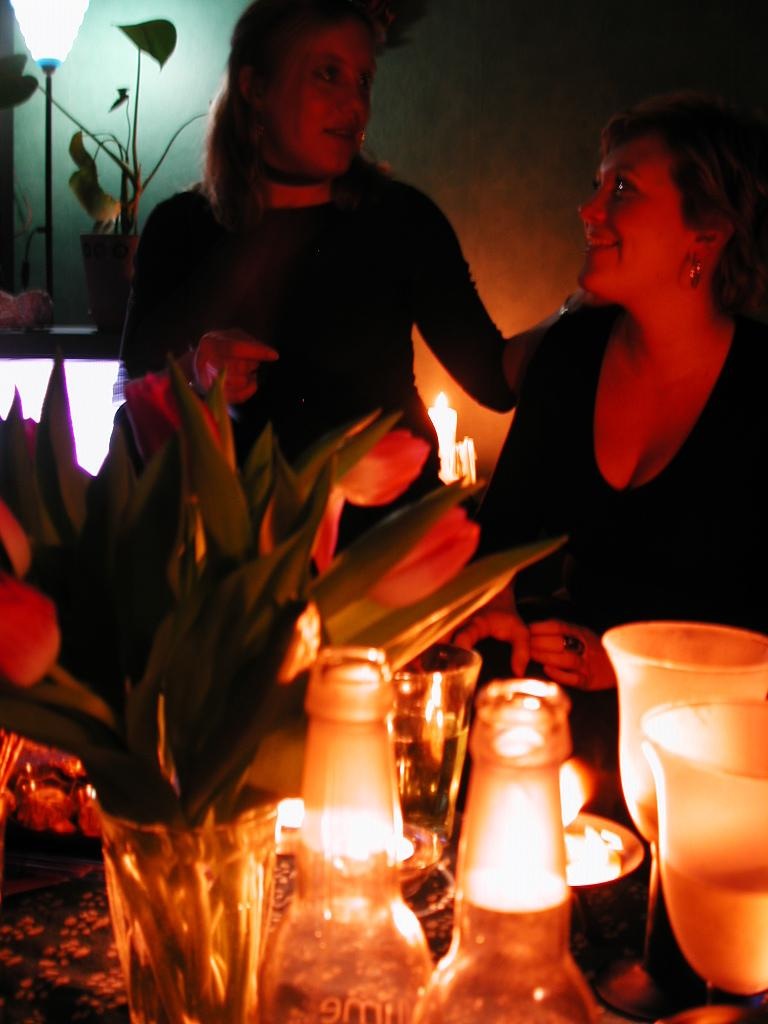How many women are in the image? There are two women in the image. What are the women doing in the image? The women are talking to each other and smiling. What can be seen in the background of the image? There is a wall visible in the background of the image. What objects are present in the image that might be used for drinking? There are glasses and bottles in the image. What decorative item can be seen in the image? There is a vase with flowers in it in the image. What language are the women speaking in the image? The image does not provide any information about the language being spoken by the women. Can you tell me how much debt the women have in the image? There is no information about the women's debt in the image. 